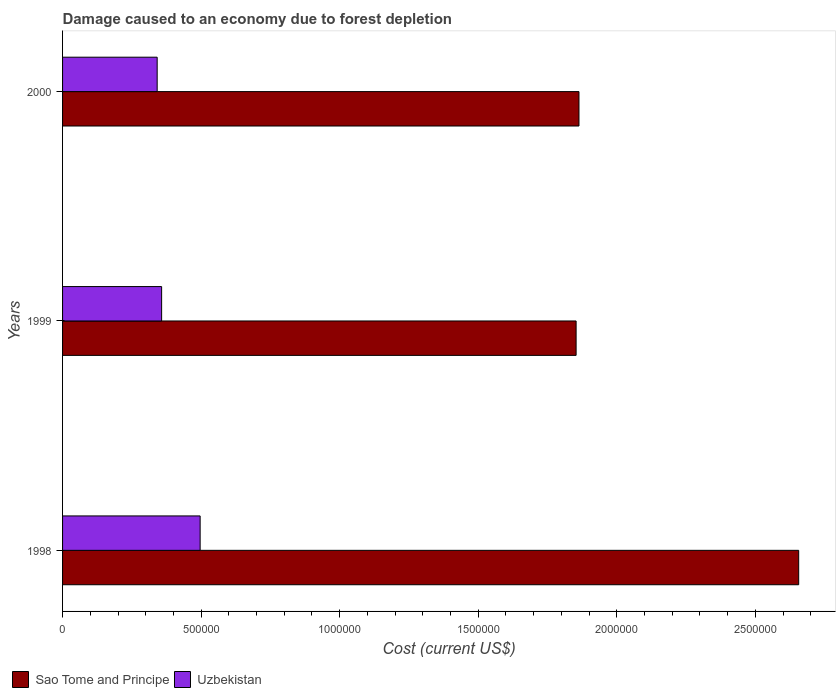Are the number of bars per tick equal to the number of legend labels?
Your answer should be very brief. Yes. Are the number of bars on each tick of the Y-axis equal?
Give a very brief answer. Yes. How many bars are there on the 3rd tick from the bottom?
Your answer should be compact. 2. What is the label of the 1st group of bars from the top?
Provide a succinct answer. 2000. In how many cases, is the number of bars for a given year not equal to the number of legend labels?
Keep it short and to the point. 0. What is the cost of damage caused due to forest depletion in Sao Tome and Principe in 1998?
Give a very brief answer. 2.66e+06. Across all years, what is the maximum cost of damage caused due to forest depletion in Uzbekistan?
Provide a short and direct response. 4.96e+05. Across all years, what is the minimum cost of damage caused due to forest depletion in Sao Tome and Principe?
Keep it short and to the point. 1.85e+06. What is the total cost of damage caused due to forest depletion in Sao Tome and Principe in the graph?
Keep it short and to the point. 6.37e+06. What is the difference between the cost of damage caused due to forest depletion in Sao Tome and Principe in 1998 and that in 1999?
Provide a short and direct response. 8.03e+05. What is the difference between the cost of damage caused due to forest depletion in Uzbekistan in 1998 and the cost of damage caused due to forest depletion in Sao Tome and Principe in 1999?
Keep it short and to the point. -1.36e+06. What is the average cost of damage caused due to forest depletion in Sao Tome and Principe per year?
Give a very brief answer. 2.12e+06. In the year 2000, what is the difference between the cost of damage caused due to forest depletion in Uzbekistan and cost of damage caused due to forest depletion in Sao Tome and Principe?
Offer a very short reply. -1.52e+06. What is the ratio of the cost of damage caused due to forest depletion in Sao Tome and Principe in 1999 to that in 2000?
Ensure brevity in your answer.  0.99. What is the difference between the highest and the second highest cost of damage caused due to forest depletion in Uzbekistan?
Keep it short and to the point. 1.39e+05. What is the difference between the highest and the lowest cost of damage caused due to forest depletion in Uzbekistan?
Offer a very short reply. 1.55e+05. In how many years, is the cost of damage caused due to forest depletion in Sao Tome and Principe greater than the average cost of damage caused due to forest depletion in Sao Tome and Principe taken over all years?
Keep it short and to the point. 1. What does the 1st bar from the top in 1998 represents?
Offer a terse response. Uzbekistan. What does the 1st bar from the bottom in 1998 represents?
Your response must be concise. Sao Tome and Principe. Are all the bars in the graph horizontal?
Give a very brief answer. Yes. Are the values on the major ticks of X-axis written in scientific E-notation?
Make the answer very short. No. Does the graph contain any zero values?
Provide a short and direct response. No. How are the legend labels stacked?
Offer a very short reply. Horizontal. What is the title of the graph?
Provide a short and direct response. Damage caused to an economy due to forest depletion. What is the label or title of the X-axis?
Your response must be concise. Cost (current US$). What is the label or title of the Y-axis?
Make the answer very short. Years. What is the Cost (current US$) of Sao Tome and Principe in 1998?
Your answer should be compact. 2.66e+06. What is the Cost (current US$) in Uzbekistan in 1998?
Provide a succinct answer. 4.96e+05. What is the Cost (current US$) in Sao Tome and Principe in 1999?
Provide a succinct answer. 1.85e+06. What is the Cost (current US$) of Uzbekistan in 1999?
Make the answer very short. 3.57e+05. What is the Cost (current US$) of Sao Tome and Principe in 2000?
Ensure brevity in your answer.  1.86e+06. What is the Cost (current US$) in Uzbekistan in 2000?
Make the answer very short. 3.41e+05. Across all years, what is the maximum Cost (current US$) of Sao Tome and Principe?
Give a very brief answer. 2.66e+06. Across all years, what is the maximum Cost (current US$) in Uzbekistan?
Your answer should be compact. 4.96e+05. Across all years, what is the minimum Cost (current US$) in Sao Tome and Principe?
Offer a very short reply. 1.85e+06. Across all years, what is the minimum Cost (current US$) of Uzbekistan?
Provide a short and direct response. 3.41e+05. What is the total Cost (current US$) of Sao Tome and Principe in the graph?
Your answer should be very brief. 6.37e+06. What is the total Cost (current US$) of Uzbekistan in the graph?
Give a very brief answer. 1.20e+06. What is the difference between the Cost (current US$) in Sao Tome and Principe in 1998 and that in 1999?
Keep it short and to the point. 8.03e+05. What is the difference between the Cost (current US$) in Uzbekistan in 1998 and that in 1999?
Keep it short and to the point. 1.39e+05. What is the difference between the Cost (current US$) in Sao Tome and Principe in 1998 and that in 2000?
Your answer should be very brief. 7.93e+05. What is the difference between the Cost (current US$) in Uzbekistan in 1998 and that in 2000?
Keep it short and to the point. 1.55e+05. What is the difference between the Cost (current US$) in Sao Tome and Principe in 1999 and that in 2000?
Ensure brevity in your answer.  -1.03e+04. What is the difference between the Cost (current US$) in Uzbekistan in 1999 and that in 2000?
Your answer should be very brief. 1.61e+04. What is the difference between the Cost (current US$) of Sao Tome and Principe in 1998 and the Cost (current US$) of Uzbekistan in 1999?
Make the answer very short. 2.30e+06. What is the difference between the Cost (current US$) of Sao Tome and Principe in 1998 and the Cost (current US$) of Uzbekistan in 2000?
Ensure brevity in your answer.  2.31e+06. What is the difference between the Cost (current US$) in Sao Tome and Principe in 1999 and the Cost (current US$) in Uzbekistan in 2000?
Your response must be concise. 1.51e+06. What is the average Cost (current US$) of Sao Tome and Principe per year?
Ensure brevity in your answer.  2.12e+06. What is the average Cost (current US$) in Uzbekistan per year?
Give a very brief answer. 3.98e+05. In the year 1998, what is the difference between the Cost (current US$) of Sao Tome and Principe and Cost (current US$) of Uzbekistan?
Provide a succinct answer. 2.16e+06. In the year 1999, what is the difference between the Cost (current US$) of Sao Tome and Principe and Cost (current US$) of Uzbekistan?
Offer a very short reply. 1.50e+06. In the year 2000, what is the difference between the Cost (current US$) of Sao Tome and Principe and Cost (current US$) of Uzbekistan?
Your response must be concise. 1.52e+06. What is the ratio of the Cost (current US$) in Sao Tome and Principe in 1998 to that in 1999?
Provide a succinct answer. 1.43. What is the ratio of the Cost (current US$) of Uzbekistan in 1998 to that in 1999?
Offer a terse response. 1.39. What is the ratio of the Cost (current US$) of Sao Tome and Principe in 1998 to that in 2000?
Make the answer very short. 1.43. What is the ratio of the Cost (current US$) in Uzbekistan in 1998 to that in 2000?
Offer a very short reply. 1.45. What is the ratio of the Cost (current US$) in Uzbekistan in 1999 to that in 2000?
Offer a terse response. 1.05. What is the difference between the highest and the second highest Cost (current US$) in Sao Tome and Principe?
Keep it short and to the point. 7.93e+05. What is the difference between the highest and the second highest Cost (current US$) in Uzbekistan?
Keep it short and to the point. 1.39e+05. What is the difference between the highest and the lowest Cost (current US$) of Sao Tome and Principe?
Make the answer very short. 8.03e+05. What is the difference between the highest and the lowest Cost (current US$) in Uzbekistan?
Provide a short and direct response. 1.55e+05. 